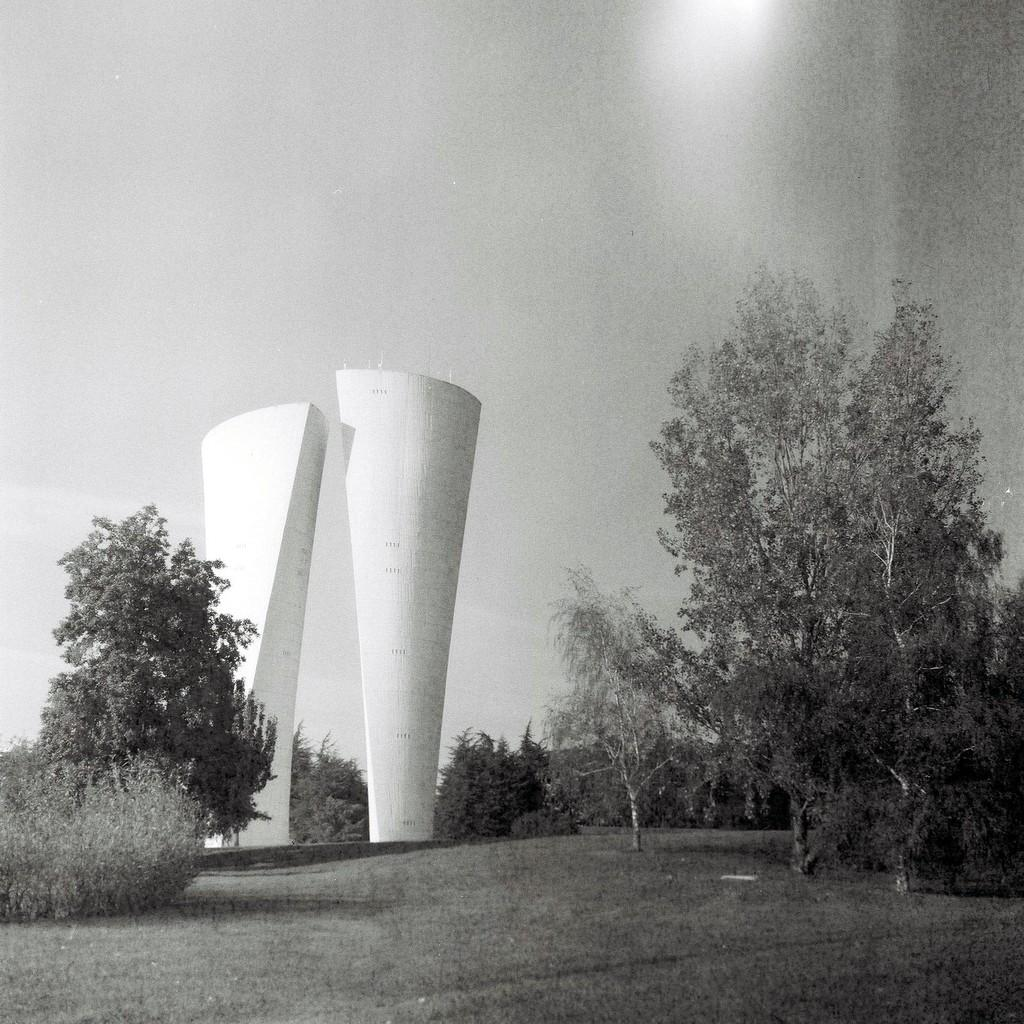What type of surface is visible in the image? There is a grass surface in the image. What other natural elements can be seen in the image? There are plants and trees in the image. What type of structures are present in the image? There are constructions in the image, which are white in color. What can be seen in the background of the image? The sky is visible in the background of the image. Can you see anyone giving a kiss in the image? There is no indication of a kiss or any people in the image. How many heads can be counted in the image? There are no people or heads visible in the image. 